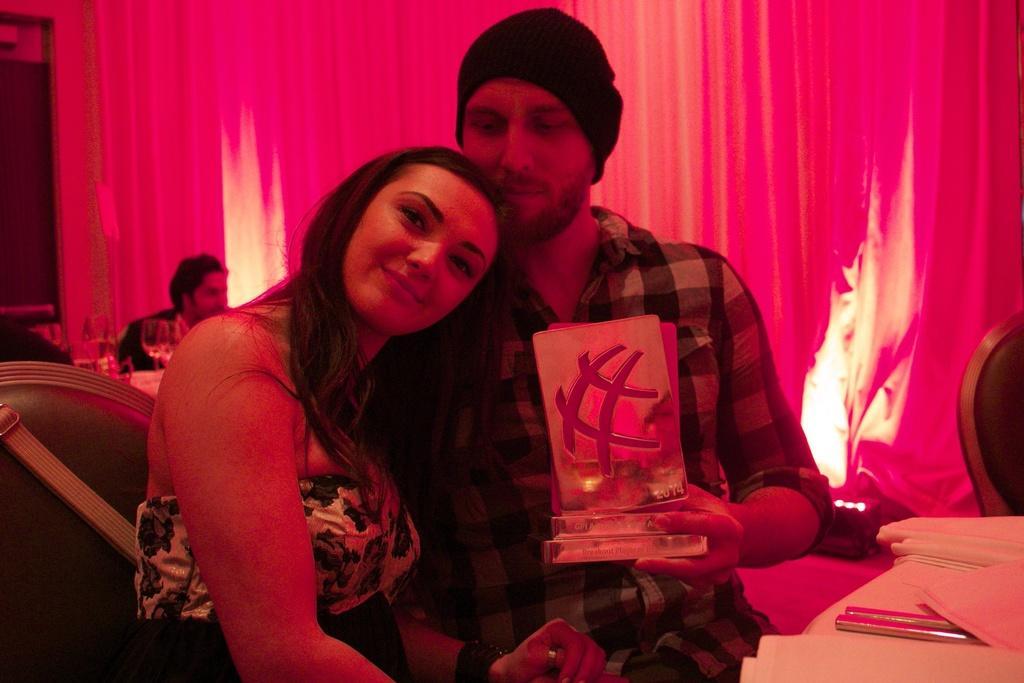Can you describe this image briefly? In the image we can see a man and a woman sitting, they are wearing clothes. This is a cloth, object, cap, curtains, wine glasses, chair. Behind them there are two people sitting. 